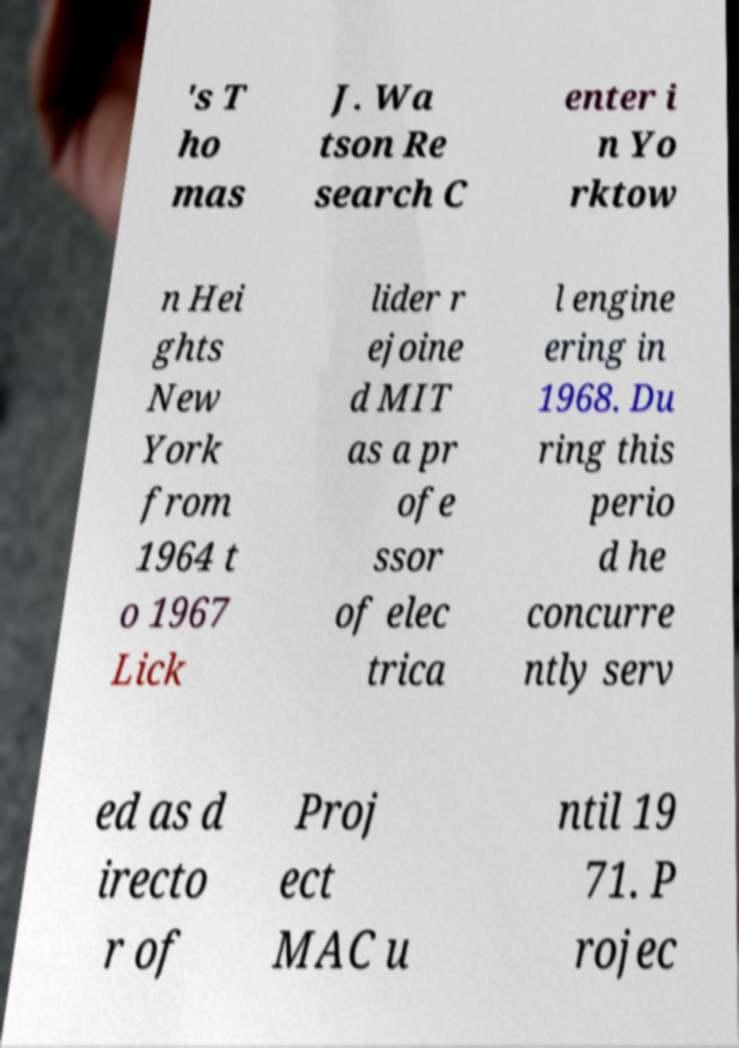Could you assist in decoding the text presented in this image and type it out clearly? 's T ho mas J. Wa tson Re search C enter i n Yo rktow n Hei ghts New York from 1964 t o 1967 Lick lider r ejoine d MIT as a pr ofe ssor of elec trica l engine ering in 1968. Du ring this perio d he concurre ntly serv ed as d irecto r of Proj ect MAC u ntil 19 71. P rojec 